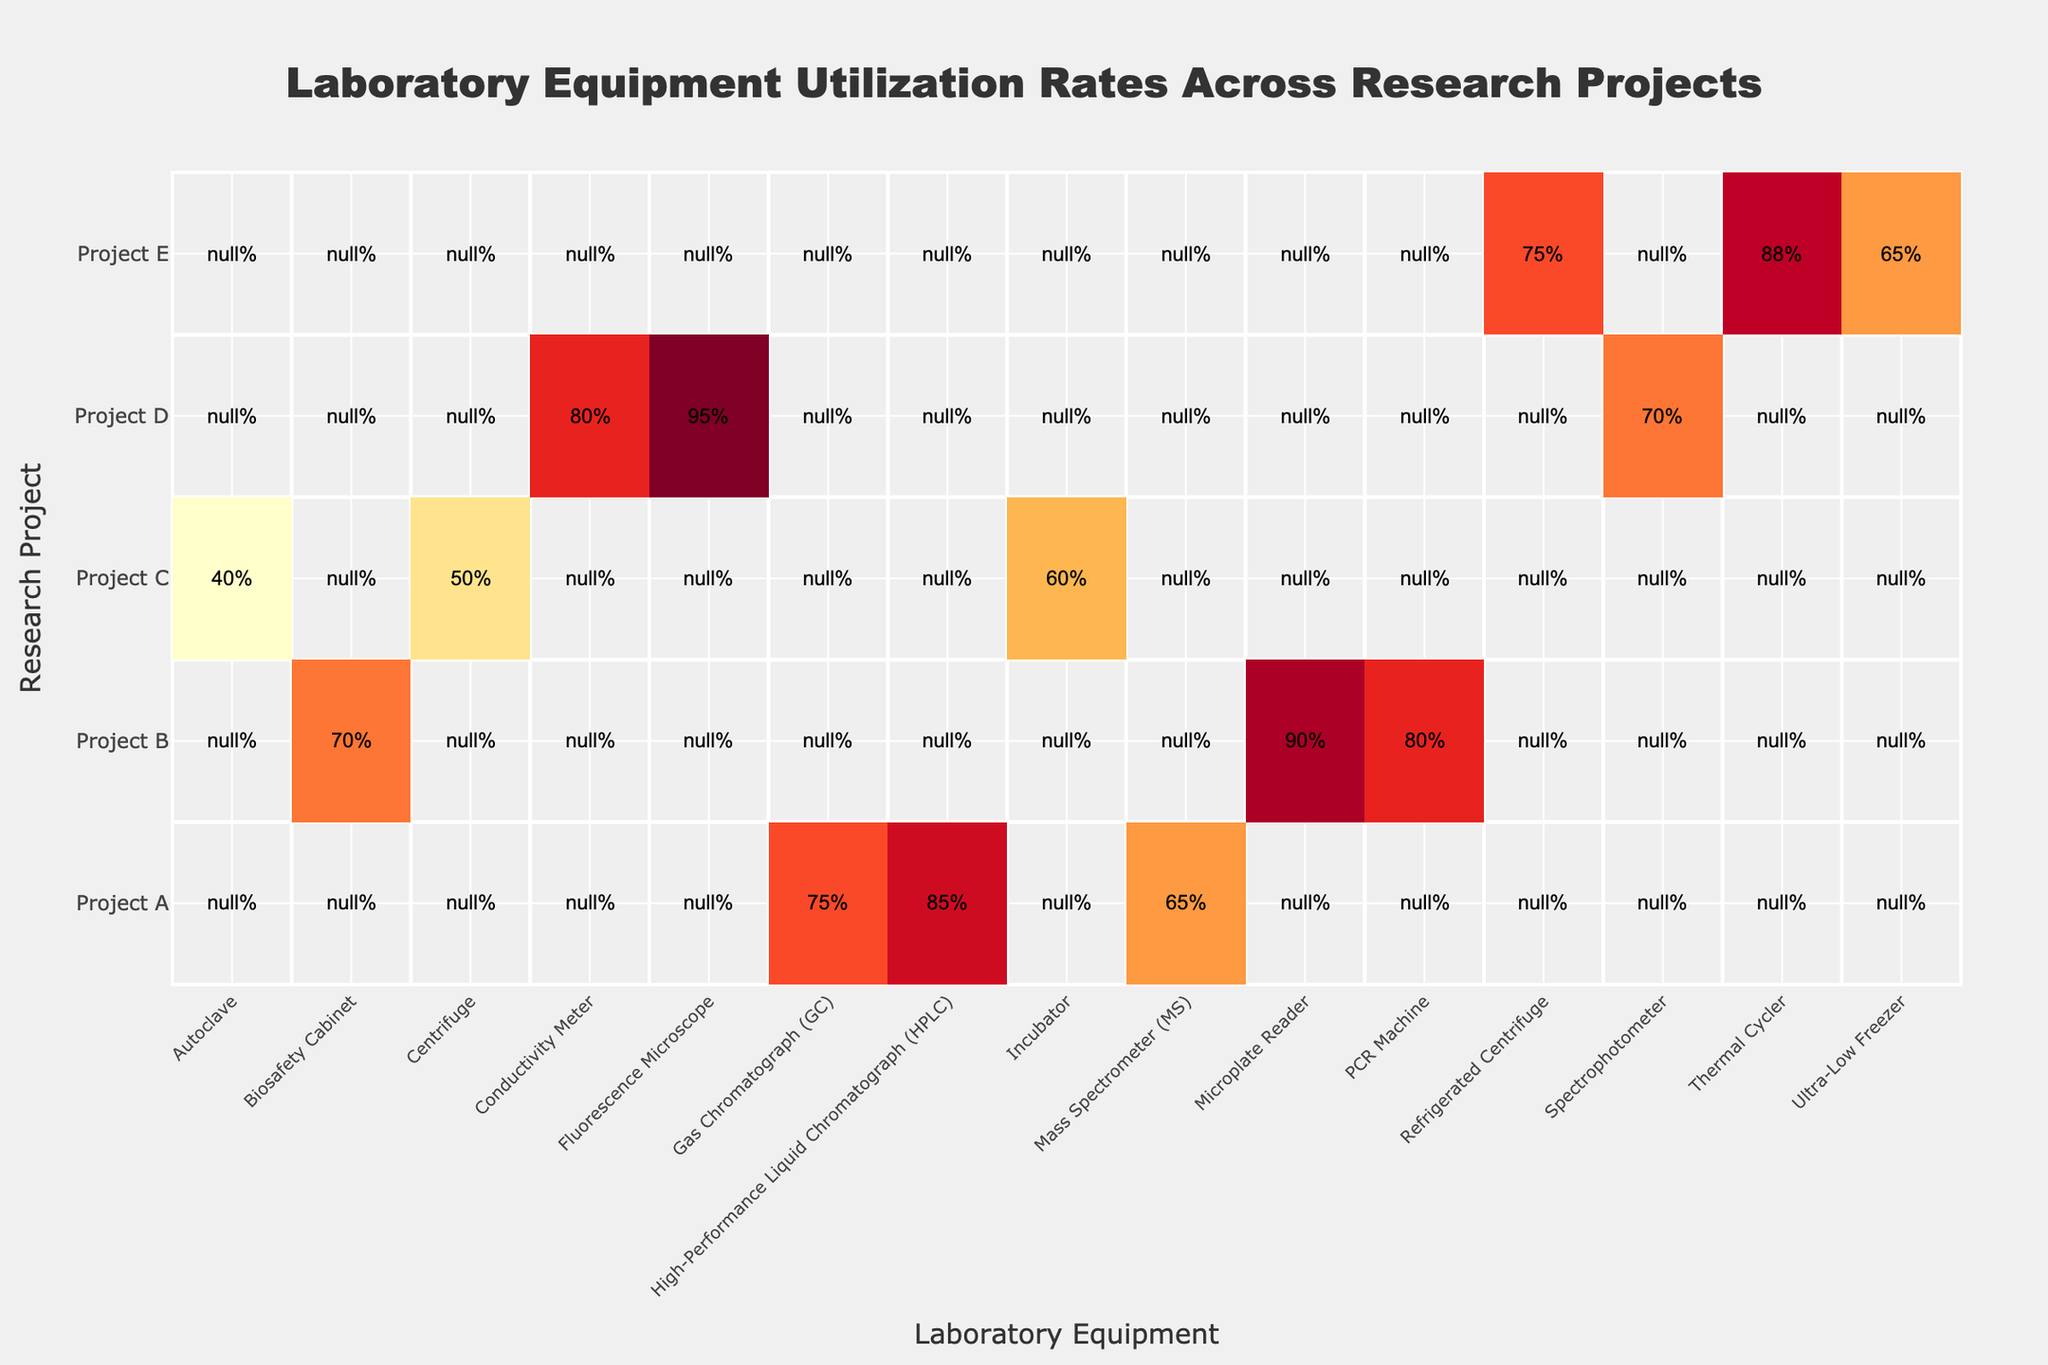What is the utilization rate of the High-Performance Liquid Chromatograph in Project A? The table clearly shows that the utilization rate for the High-Performance Liquid Chromatograph (HPLC) under Project A is 85%.
Answer: 85% Which laboratory equipment has the highest utilization rate in Project D? In Project D, the equipment with the highest utilization rate is the Fluorescence Microscope, which is utilized at a rate of 95%.
Answer: 95% What is the average utilization rate of the PCR Machine and the Biosafety Cabinet in Project B? The utilization rate of the PCR Machine is 80% and the Biosafety Cabinet is 70%. To calculate the average, we sum these two rates: (80 + 70) = 150. Then we divide by the number of equipment (2) to get the average: 150 / 2 = 75%.
Answer: 75% Is the utilization rate of the Autoclave in Project C higher than 50%? The utilization rate of the Autoclave in Project C is 40%, which is lower than 50%. Therefore, the answer is no.
Answer: No Which project has the lowest overall equipment utilization rate based on the listed equipment? To determine this, we look at all the equipment utilization rates for each project. Project C has rates of 60%, 50%, and 40%, giving a total of 150%, which averages to 50%. This is lower than any other project's average.
Answer: Project C What is the total utilization rate for all laboratory equipment in Project E? Project E has three pieces of equipment with utilization rates: Thermal Cycler (88%), Refrigerated Centrifuge (75%), and Ultra-Low Freezer (65%). The total utilization would be calculated as the sum of these values: 88 + 75 + 65 = 228%.
Answer: 228% Which project utilizes the Centrifuge and what is its utilization rate? The Centrifuge is utilized in Project C at a rate of 50%. The table confirms this information directly.
Answer: Project C, 50% Is the total utilization rate of laboratory equipment in Project A higher than 220%? For Project A, the equipment utilization rates are 85%, 75%, and 65%. Summing these yields 85 + 75 + 65 = 225%. Since 225% is greater than 220%, the answer is yes.
Answer: Yes What is the difference in utilization rates between the Fluorescence Microscope and the Conductivity Meter in Project D? The Fluorescence Microscope has a utilization rate of 95%, and the Conductivity Meter has 80%. The difference can be calculated as 95 - 80 = 15%.
Answer: 15% 